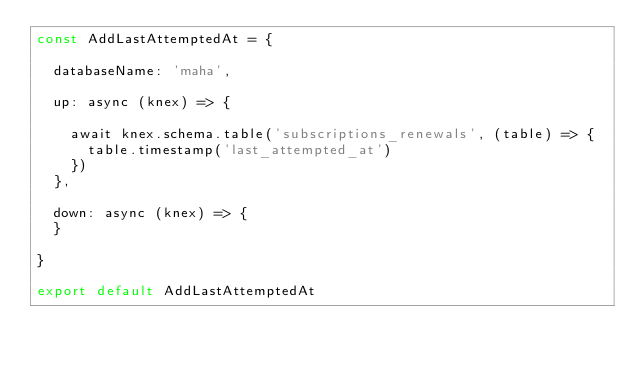Convert code to text. <code><loc_0><loc_0><loc_500><loc_500><_JavaScript_>const AddLastAttemptedAt = {

  databaseName: 'maha',

  up: async (knex) => {

    await knex.schema.table('subscriptions_renewals', (table) => {
      table.timestamp('last_attempted_at')
    })
  },

  down: async (knex) => {
  }

}

export default AddLastAttemptedAt
</code> 